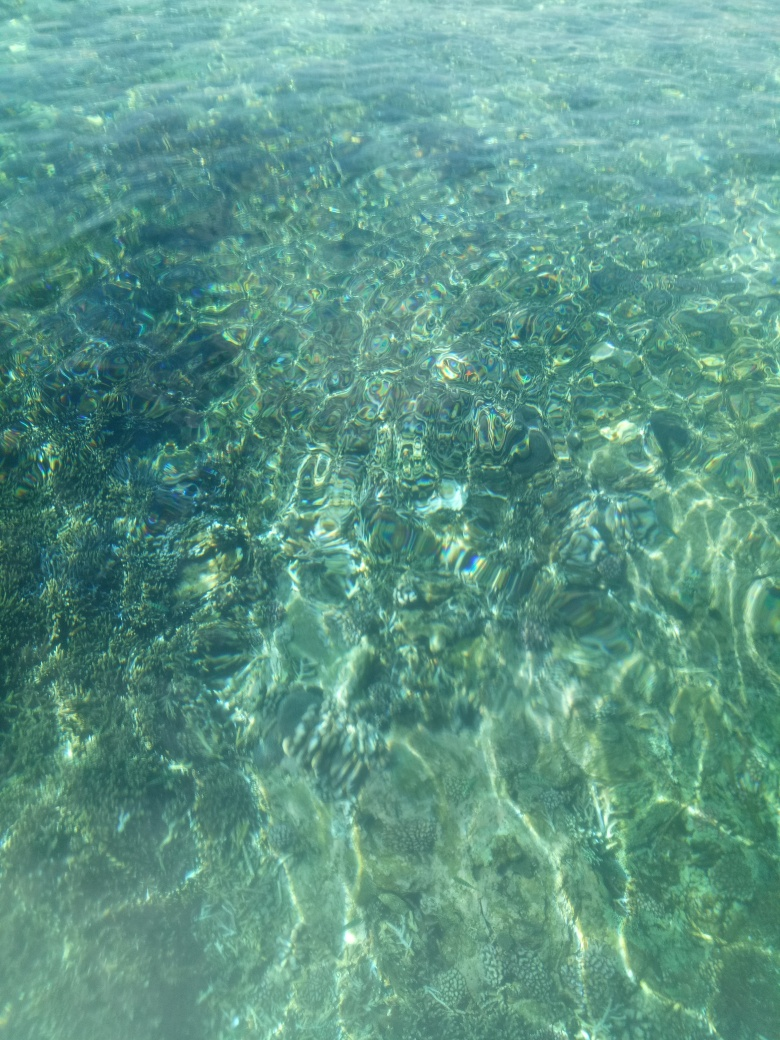Can you suggest what type of water body this is? The water clarity and visible underwater terrain suggest it might be a picture of a natural environment such as a lagoon, bay, or a shallow part of a tropical sea known for clear water and healthy coral ecosystems. 